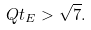Convert formula to latex. <formula><loc_0><loc_0><loc_500><loc_500>Q t _ { E } > \sqrt { 7 } .</formula> 